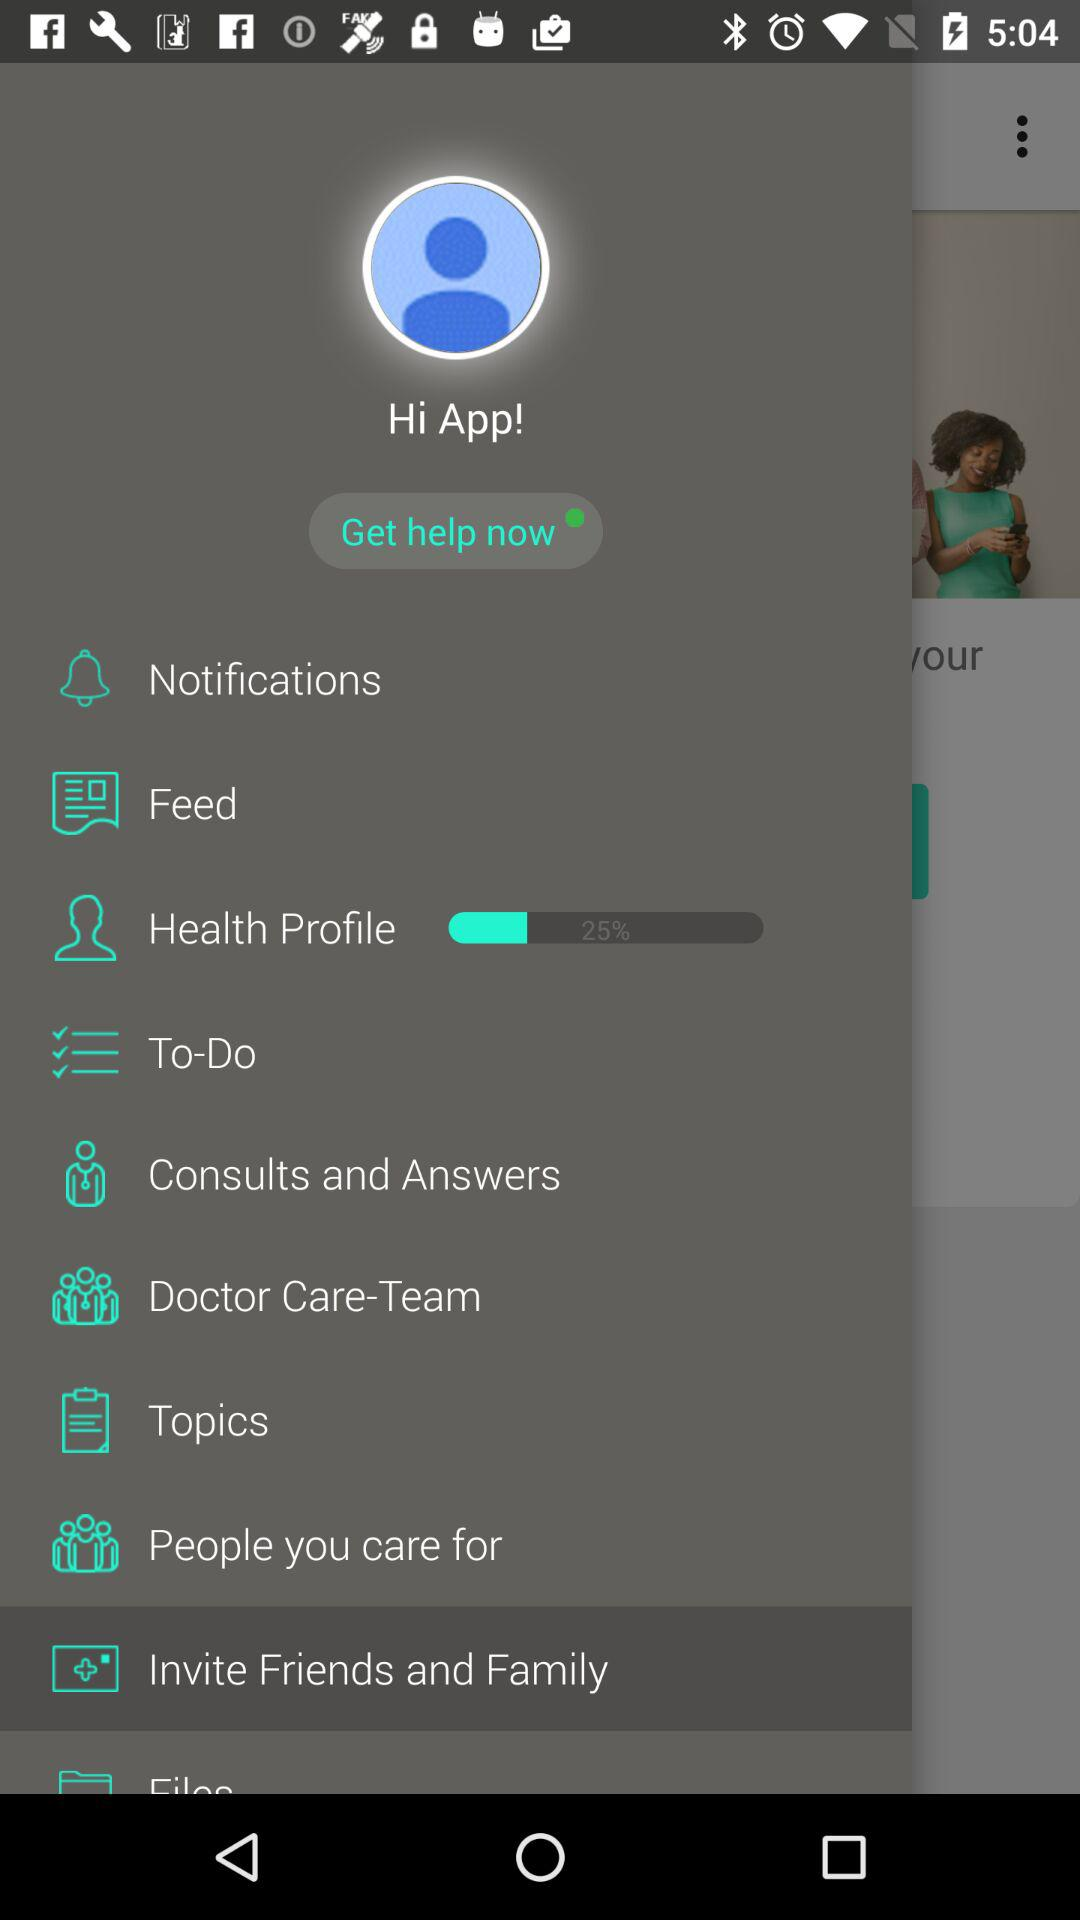What is the name of the application? The application name is "Hi App!". 